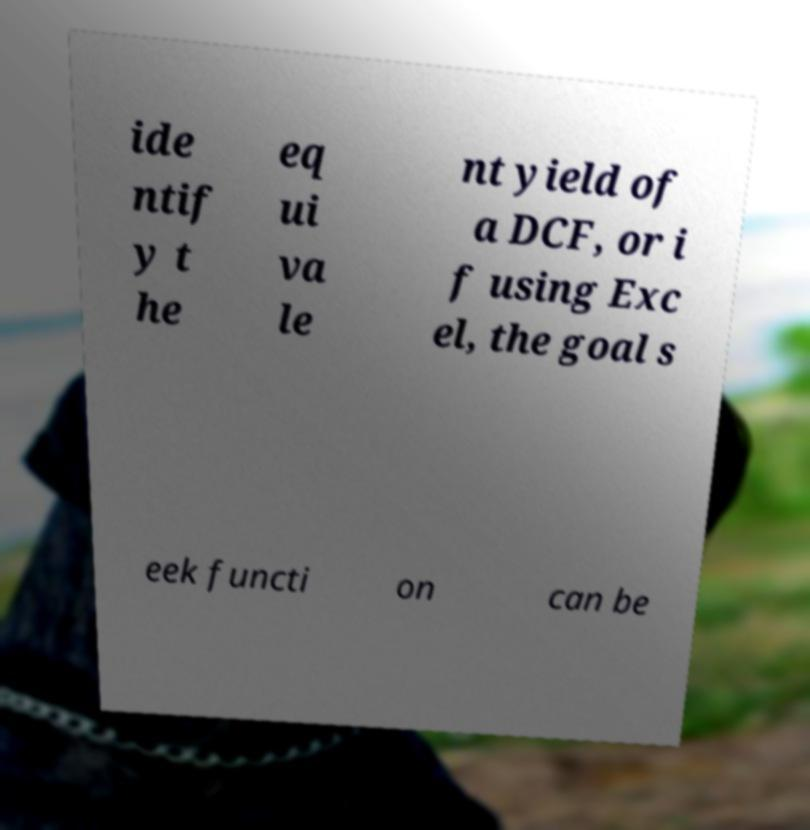Can you accurately transcribe the text from the provided image for me? ide ntif y t he eq ui va le nt yield of a DCF, or i f using Exc el, the goal s eek functi on can be 